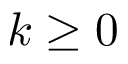<formula> <loc_0><loc_0><loc_500><loc_500>k \geq 0</formula> 